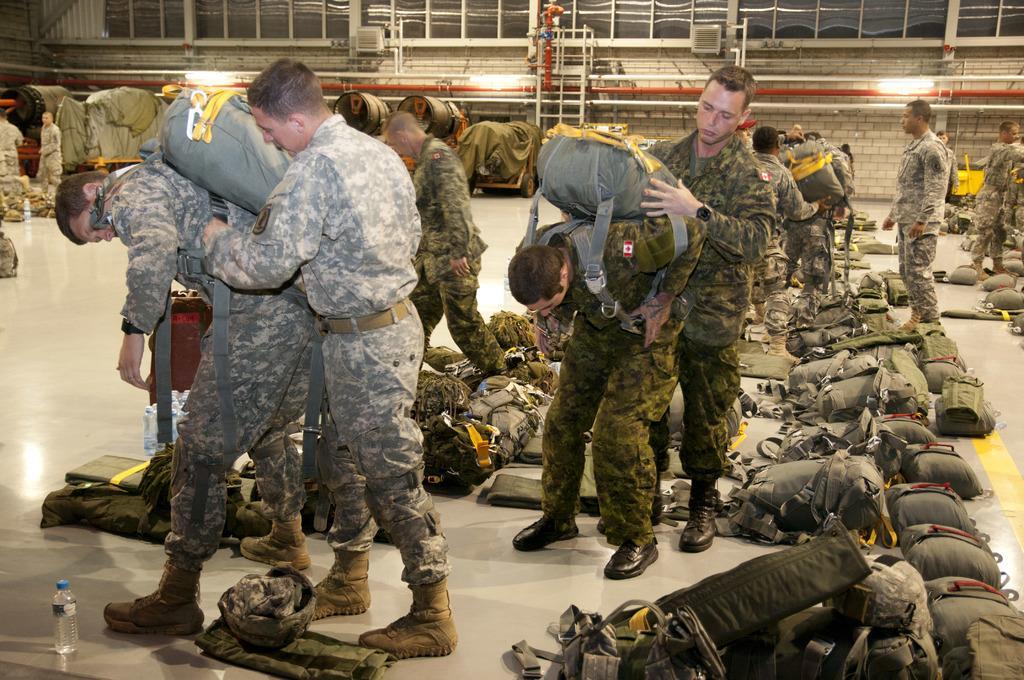Can you describe this image briefly? In this image we can see people standing. They are all wearing uniforms and there are some people wearing bags. At the bottom there are bottles and bags placed on the floor. In the background there is a wall and lights. We can see trolleys. 